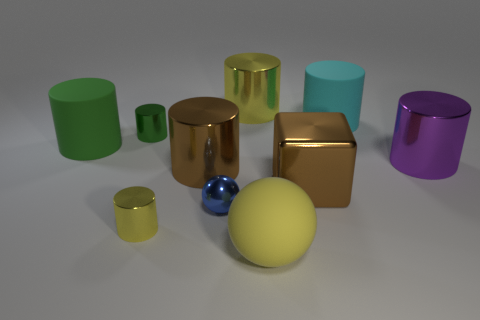Does the metallic sphere have the same color as the cube?
Your answer should be very brief. No. Is the number of purple things that are right of the brown cube less than the number of small yellow balls?
Give a very brief answer. No. There is a small cylinder that is in front of the green shiny cylinder; what color is it?
Give a very brief answer. Yellow. There is a green rubber object; what shape is it?
Your answer should be compact. Cylinder. There is a yellow metal cylinder behind the cylinder in front of the big brown metal cylinder; are there any brown metal objects in front of it?
Give a very brief answer. Yes. What color is the object that is to the left of the metal thing that is left of the small yellow metal thing left of the cyan cylinder?
Provide a short and direct response. Green. What is the material of the other object that is the same shape as the large yellow matte thing?
Give a very brief answer. Metal. What size is the yellow cylinder in front of the yellow cylinder that is behind the green matte object?
Ensure brevity in your answer.  Small. What material is the brown thing that is behind the big brown block?
Offer a terse response. Metal. The block that is the same material as the purple object is what size?
Make the answer very short. Large. 